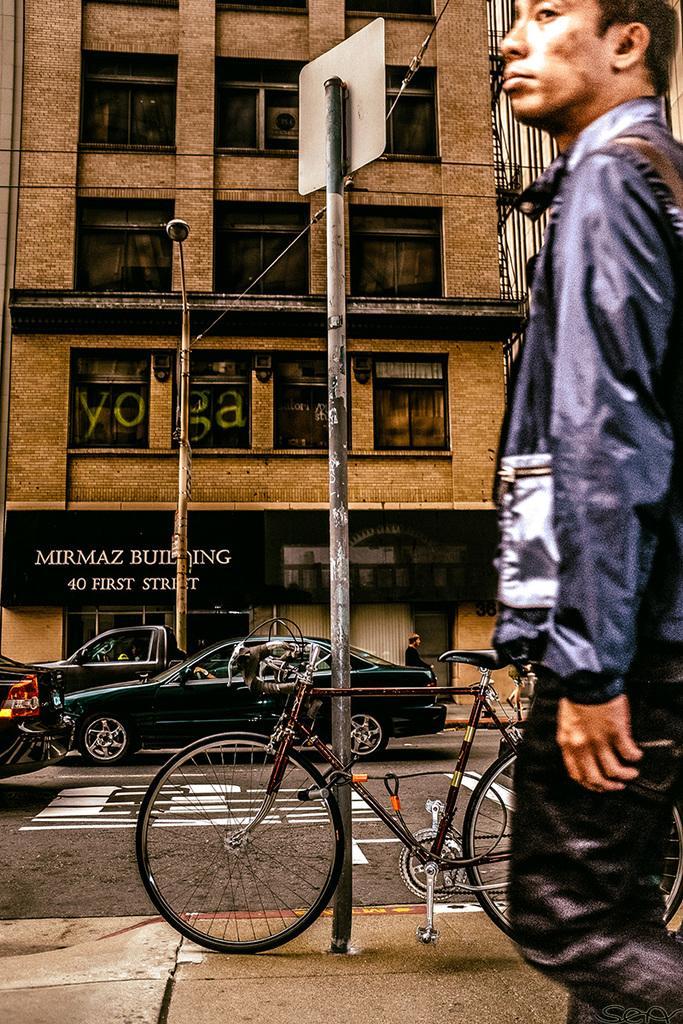How would you summarize this image in a sentence or two? In this image on the right side we can see a man and there is a bicycle on a footpath at the pole and we can see vehicles on the road, a person, building, windows and a hoarding on the wall. 